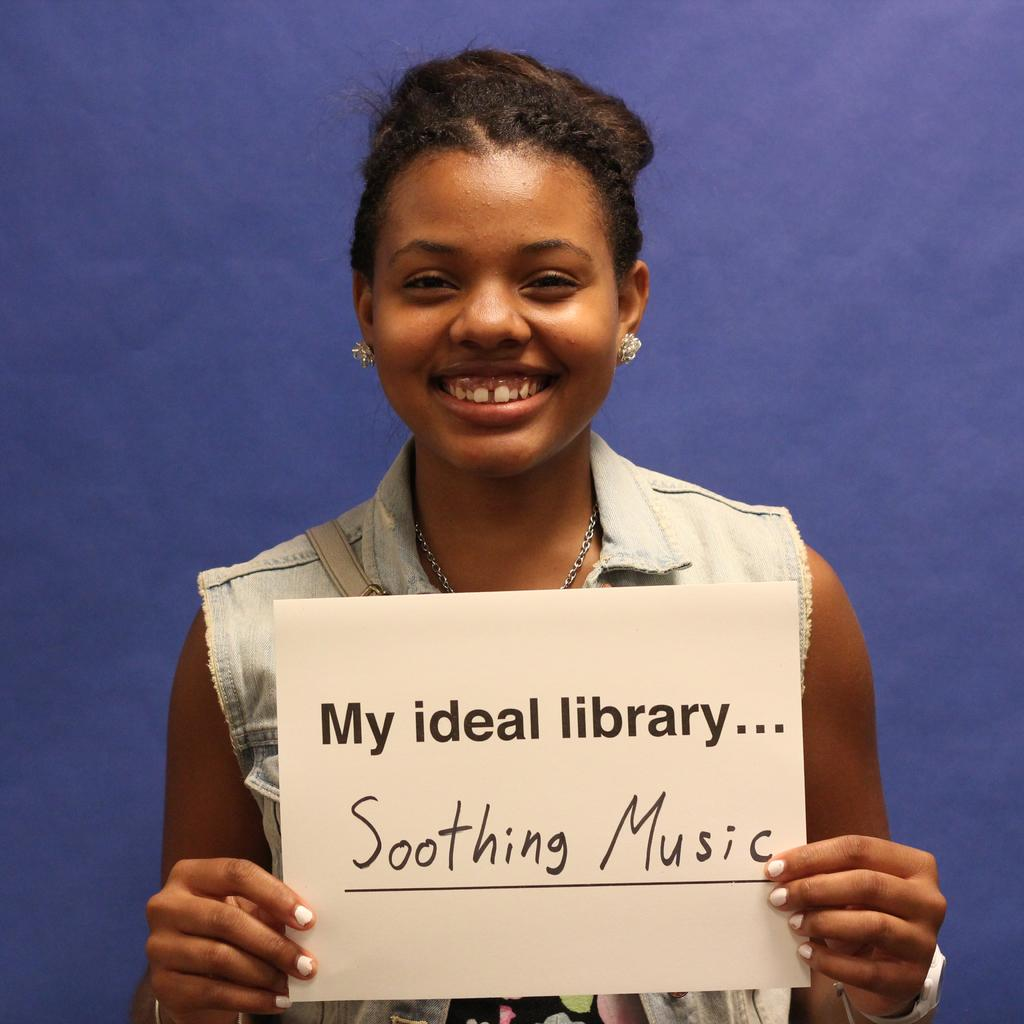What is the woman doing in the image? The woman is standing in the image. What is the woman holding in the image? The woman is holding a white color paper. What can be seen in the background of the image? There is a blue color wall in the background of the image. What type of worm can be seen crawling on the blue color wall in the image? There is no worm present in the image; the background features a blue color wall without any visible worms. 